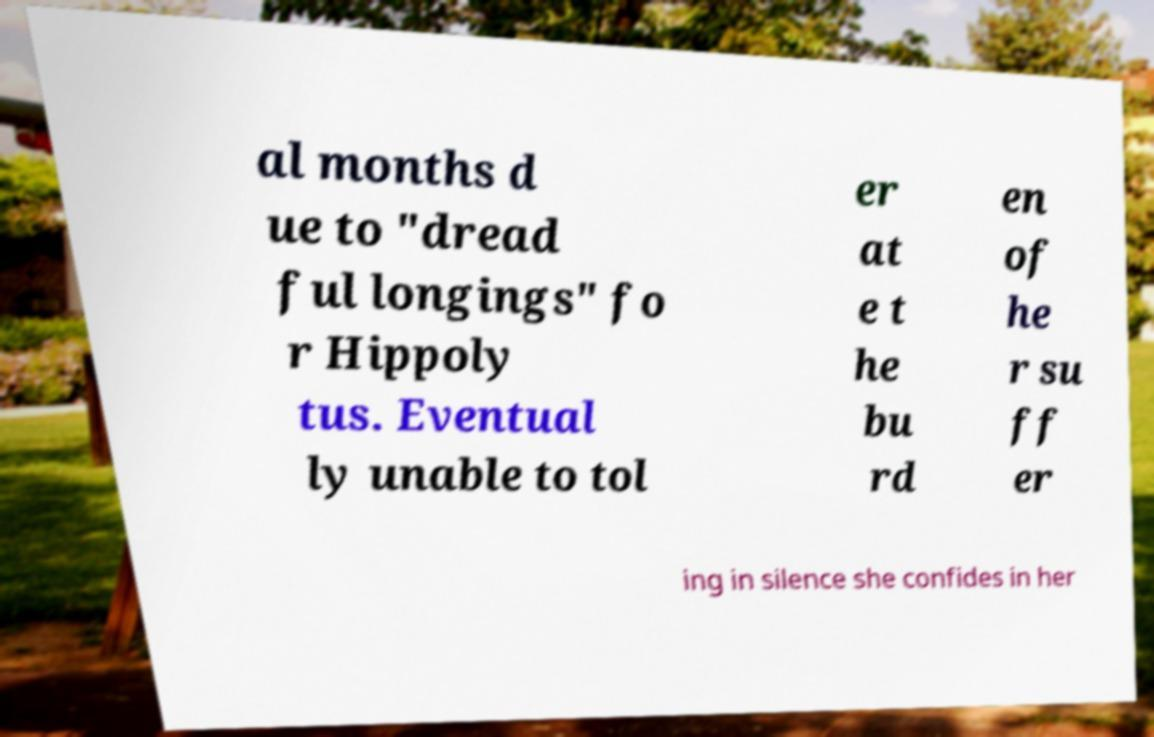There's text embedded in this image that I need extracted. Can you transcribe it verbatim? al months d ue to "dread ful longings" fo r Hippoly tus. Eventual ly unable to tol er at e t he bu rd en of he r su ff er ing in silence she confides in her 